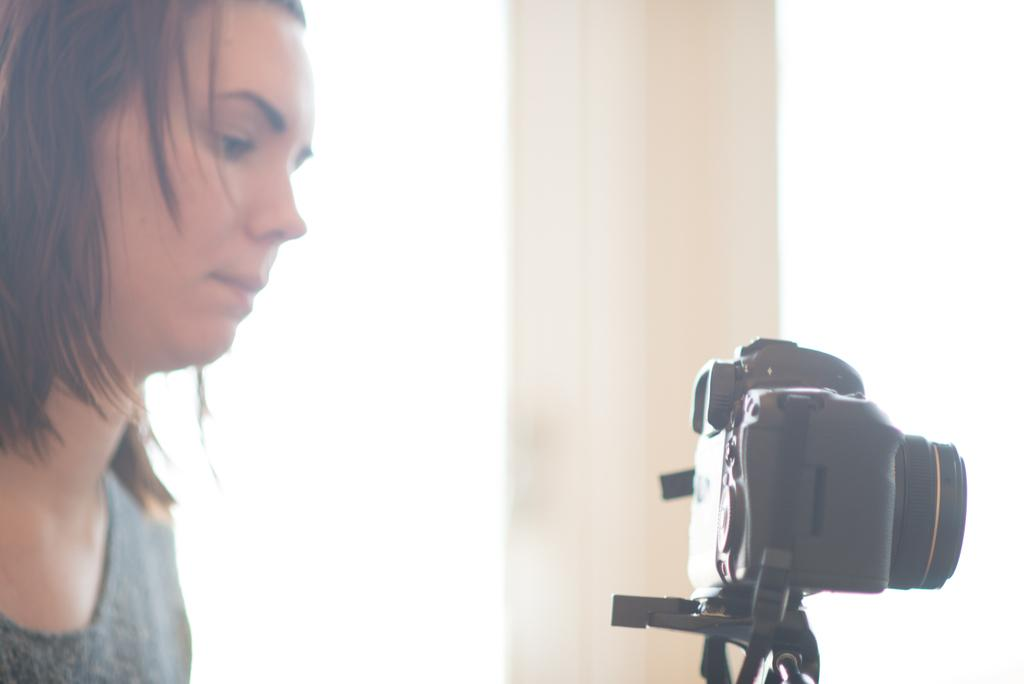What is the main subject of the image? There is a person in the image. What object is in front of the person? There is a camera in front of the person. What color is the background of the image? The background of the image is white. What type of pain is the person experiencing in the image? There is no indication in the image that the person is experiencing any pain. What arithmetic problem is the person solving in the image? There is no arithmetic problem visible in the image. 